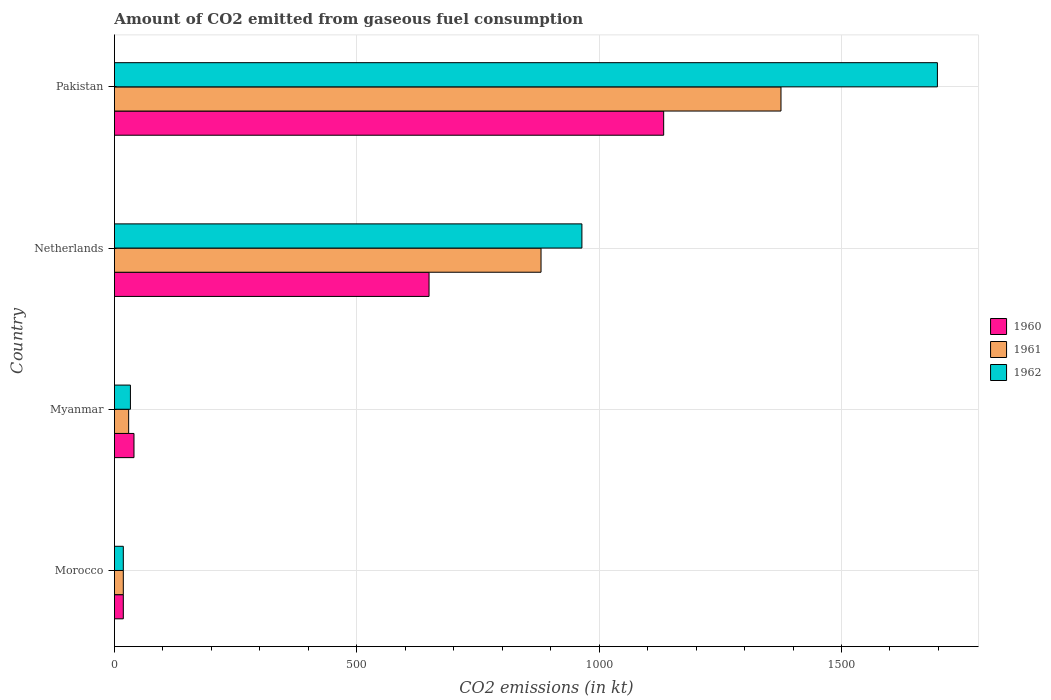How many groups of bars are there?
Give a very brief answer. 4. Are the number of bars on each tick of the Y-axis equal?
Your answer should be compact. Yes. What is the label of the 1st group of bars from the top?
Give a very brief answer. Pakistan. What is the amount of CO2 emitted in 1961 in Morocco?
Your answer should be very brief. 18.34. Across all countries, what is the maximum amount of CO2 emitted in 1962?
Provide a short and direct response. 1697.82. Across all countries, what is the minimum amount of CO2 emitted in 1960?
Your answer should be very brief. 18.34. In which country was the amount of CO2 emitted in 1960 minimum?
Your answer should be compact. Morocco. What is the total amount of CO2 emitted in 1962 in the graph?
Your response must be concise. 2713.58. What is the difference between the amount of CO2 emitted in 1962 in Morocco and that in Myanmar?
Your response must be concise. -14.67. What is the difference between the amount of CO2 emitted in 1961 in Netherlands and the amount of CO2 emitted in 1962 in Morocco?
Provide a succinct answer. 861.75. What is the average amount of CO2 emitted in 1960 per country?
Ensure brevity in your answer.  460.21. What is the difference between the amount of CO2 emitted in 1962 and amount of CO2 emitted in 1961 in Myanmar?
Your answer should be very brief. 3.67. In how many countries, is the amount of CO2 emitted in 1962 greater than 400 kt?
Provide a short and direct response. 2. What is the ratio of the amount of CO2 emitted in 1960 in Morocco to that in Pakistan?
Keep it short and to the point. 0.02. Is the difference between the amount of CO2 emitted in 1962 in Morocco and Myanmar greater than the difference between the amount of CO2 emitted in 1961 in Morocco and Myanmar?
Give a very brief answer. No. What is the difference between the highest and the second highest amount of CO2 emitted in 1962?
Your response must be concise. 733.4. What is the difference between the highest and the lowest amount of CO2 emitted in 1960?
Your response must be concise. 1114.77. In how many countries, is the amount of CO2 emitted in 1960 greater than the average amount of CO2 emitted in 1960 taken over all countries?
Offer a very short reply. 2. What does the 2nd bar from the top in Myanmar represents?
Provide a short and direct response. 1961. Is it the case that in every country, the sum of the amount of CO2 emitted in 1961 and amount of CO2 emitted in 1960 is greater than the amount of CO2 emitted in 1962?
Your response must be concise. Yes. Are all the bars in the graph horizontal?
Provide a short and direct response. Yes. How many countries are there in the graph?
Provide a short and direct response. 4. Are the values on the major ticks of X-axis written in scientific E-notation?
Your response must be concise. No. How are the legend labels stacked?
Make the answer very short. Vertical. What is the title of the graph?
Your answer should be compact. Amount of CO2 emitted from gaseous fuel consumption. What is the label or title of the X-axis?
Ensure brevity in your answer.  CO2 emissions (in kt). What is the CO2 emissions (in kt) in 1960 in Morocco?
Your answer should be very brief. 18.34. What is the CO2 emissions (in kt) of 1961 in Morocco?
Provide a succinct answer. 18.34. What is the CO2 emissions (in kt) in 1962 in Morocco?
Your response must be concise. 18.34. What is the CO2 emissions (in kt) in 1960 in Myanmar?
Keep it short and to the point. 40.34. What is the CO2 emissions (in kt) of 1961 in Myanmar?
Your response must be concise. 29.34. What is the CO2 emissions (in kt) in 1962 in Myanmar?
Provide a short and direct response. 33. What is the CO2 emissions (in kt) in 1960 in Netherlands?
Make the answer very short. 649.06. What is the CO2 emissions (in kt) of 1961 in Netherlands?
Provide a succinct answer. 880.08. What is the CO2 emissions (in kt) in 1962 in Netherlands?
Offer a terse response. 964.42. What is the CO2 emissions (in kt) of 1960 in Pakistan?
Provide a succinct answer. 1133.1. What is the CO2 emissions (in kt) of 1961 in Pakistan?
Your response must be concise. 1375.12. What is the CO2 emissions (in kt) in 1962 in Pakistan?
Give a very brief answer. 1697.82. Across all countries, what is the maximum CO2 emissions (in kt) in 1960?
Keep it short and to the point. 1133.1. Across all countries, what is the maximum CO2 emissions (in kt) in 1961?
Your response must be concise. 1375.12. Across all countries, what is the maximum CO2 emissions (in kt) of 1962?
Your answer should be very brief. 1697.82. Across all countries, what is the minimum CO2 emissions (in kt) of 1960?
Keep it short and to the point. 18.34. Across all countries, what is the minimum CO2 emissions (in kt) of 1961?
Offer a terse response. 18.34. Across all countries, what is the minimum CO2 emissions (in kt) of 1962?
Keep it short and to the point. 18.34. What is the total CO2 emissions (in kt) in 1960 in the graph?
Offer a very short reply. 1840.83. What is the total CO2 emissions (in kt) of 1961 in the graph?
Give a very brief answer. 2302.88. What is the total CO2 emissions (in kt) of 1962 in the graph?
Offer a terse response. 2713.58. What is the difference between the CO2 emissions (in kt) of 1960 in Morocco and that in Myanmar?
Your answer should be compact. -22. What is the difference between the CO2 emissions (in kt) of 1961 in Morocco and that in Myanmar?
Your answer should be compact. -11. What is the difference between the CO2 emissions (in kt) of 1962 in Morocco and that in Myanmar?
Your response must be concise. -14.67. What is the difference between the CO2 emissions (in kt) in 1960 in Morocco and that in Netherlands?
Ensure brevity in your answer.  -630.72. What is the difference between the CO2 emissions (in kt) of 1961 in Morocco and that in Netherlands?
Keep it short and to the point. -861.75. What is the difference between the CO2 emissions (in kt) of 1962 in Morocco and that in Netherlands?
Offer a very short reply. -946.09. What is the difference between the CO2 emissions (in kt) of 1960 in Morocco and that in Pakistan?
Offer a terse response. -1114.77. What is the difference between the CO2 emissions (in kt) in 1961 in Morocco and that in Pakistan?
Ensure brevity in your answer.  -1356.79. What is the difference between the CO2 emissions (in kt) in 1962 in Morocco and that in Pakistan?
Offer a terse response. -1679.49. What is the difference between the CO2 emissions (in kt) of 1960 in Myanmar and that in Netherlands?
Make the answer very short. -608.72. What is the difference between the CO2 emissions (in kt) of 1961 in Myanmar and that in Netherlands?
Ensure brevity in your answer.  -850.74. What is the difference between the CO2 emissions (in kt) of 1962 in Myanmar and that in Netherlands?
Offer a terse response. -931.42. What is the difference between the CO2 emissions (in kt) in 1960 in Myanmar and that in Pakistan?
Provide a succinct answer. -1092.77. What is the difference between the CO2 emissions (in kt) in 1961 in Myanmar and that in Pakistan?
Ensure brevity in your answer.  -1345.79. What is the difference between the CO2 emissions (in kt) in 1962 in Myanmar and that in Pakistan?
Your answer should be compact. -1664.82. What is the difference between the CO2 emissions (in kt) in 1960 in Netherlands and that in Pakistan?
Make the answer very short. -484.04. What is the difference between the CO2 emissions (in kt) in 1961 in Netherlands and that in Pakistan?
Provide a short and direct response. -495.05. What is the difference between the CO2 emissions (in kt) in 1962 in Netherlands and that in Pakistan?
Offer a terse response. -733.4. What is the difference between the CO2 emissions (in kt) of 1960 in Morocco and the CO2 emissions (in kt) of 1961 in Myanmar?
Provide a short and direct response. -11. What is the difference between the CO2 emissions (in kt) in 1960 in Morocco and the CO2 emissions (in kt) in 1962 in Myanmar?
Provide a short and direct response. -14.67. What is the difference between the CO2 emissions (in kt) of 1961 in Morocco and the CO2 emissions (in kt) of 1962 in Myanmar?
Provide a short and direct response. -14.67. What is the difference between the CO2 emissions (in kt) in 1960 in Morocco and the CO2 emissions (in kt) in 1961 in Netherlands?
Offer a very short reply. -861.75. What is the difference between the CO2 emissions (in kt) of 1960 in Morocco and the CO2 emissions (in kt) of 1962 in Netherlands?
Give a very brief answer. -946.09. What is the difference between the CO2 emissions (in kt) in 1961 in Morocco and the CO2 emissions (in kt) in 1962 in Netherlands?
Provide a short and direct response. -946.09. What is the difference between the CO2 emissions (in kt) in 1960 in Morocco and the CO2 emissions (in kt) in 1961 in Pakistan?
Keep it short and to the point. -1356.79. What is the difference between the CO2 emissions (in kt) in 1960 in Morocco and the CO2 emissions (in kt) in 1962 in Pakistan?
Provide a succinct answer. -1679.49. What is the difference between the CO2 emissions (in kt) in 1961 in Morocco and the CO2 emissions (in kt) in 1962 in Pakistan?
Your answer should be very brief. -1679.49. What is the difference between the CO2 emissions (in kt) of 1960 in Myanmar and the CO2 emissions (in kt) of 1961 in Netherlands?
Provide a short and direct response. -839.74. What is the difference between the CO2 emissions (in kt) in 1960 in Myanmar and the CO2 emissions (in kt) in 1962 in Netherlands?
Ensure brevity in your answer.  -924.08. What is the difference between the CO2 emissions (in kt) in 1961 in Myanmar and the CO2 emissions (in kt) in 1962 in Netherlands?
Ensure brevity in your answer.  -935.09. What is the difference between the CO2 emissions (in kt) of 1960 in Myanmar and the CO2 emissions (in kt) of 1961 in Pakistan?
Offer a terse response. -1334.79. What is the difference between the CO2 emissions (in kt) of 1960 in Myanmar and the CO2 emissions (in kt) of 1962 in Pakistan?
Provide a succinct answer. -1657.48. What is the difference between the CO2 emissions (in kt) in 1961 in Myanmar and the CO2 emissions (in kt) in 1962 in Pakistan?
Give a very brief answer. -1668.48. What is the difference between the CO2 emissions (in kt) of 1960 in Netherlands and the CO2 emissions (in kt) of 1961 in Pakistan?
Your response must be concise. -726.07. What is the difference between the CO2 emissions (in kt) of 1960 in Netherlands and the CO2 emissions (in kt) of 1962 in Pakistan?
Your response must be concise. -1048.76. What is the difference between the CO2 emissions (in kt) of 1961 in Netherlands and the CO2 emissions (in kt) of 1962 in Pakistan?
Offer a very short reply. -817.74. What is the average CO2 emissions (in kt) in 1960 per country?
Your answer should be very brief. 460.21. What is the average CO2 emissions (in kt) in 1961 per country?
Provide a short and direct response. 575.72. What is the average CO2 emissions (in kt) in 1962 per country?
Offer a terse response. 678.39. What is the difference between the CO2 emissions (in kt) of 1960 and CO2 emissions (in kt) of 1962 in Morocco?
Your answer should be compact. 0. What is the difference between the CO2 emissions (in kt) in 1961 and CO2 emissions (in kt) in 1962 in Morocco?
Your response must be concise. 0. What is the difference between the CO2 emissions (in kt) of 1960 and CO2 emissions (in kt) of 1961 in Myanmar?
Keep it short and to the point. 11. What is the difference between the CO2 emissions (in kt) of 1960 and CO2 emissions (in kt) of 1962 in Myanmar?
Provide a short and direct response. 7.33. What is the difference between the CO2 emissions (in kt) of 1961 and CO2 emissions (in kt) of 1962 in Myanmar?
Make the answer very short. -3.67. What is the difference between the CO2 emissions (in kt) in 1960 and CO2 emissions (in kt) in 1961 in Netherlands?
Offer a very short reply. -231.02. What is the difference between the CO2 emissions (in kt) of 1960 and CO2 emissions (in kt) of 1962 in Netherlands?
Your answer should be very brief. -315.36. What is the difference between the CO2 emissions (in kt) in 1961 and CO2 emissions (in kt) in 1962 in Netherlands?
Ensure brevity in your answer.  -84.34. What is the difference between the CO2 emissions (in kt) of 1960 and CO2 emissions (in kt) of 1961 in Pakistan?
Keep it short and to the point. -242.02. What is the difference between the CO2 emissions (in kt) of 1960 and CO2 emissions (in kt) of 1962 in Pakistan?
Your response must be concise. -564.72. What is the difference between the CO2 emissions (in kt) of 1961 and CO2 emissions (in kt) of 1962 in Pakistan?
Offer a terse response. -322.7. What is the ratio of the CO2 emissions (in kt) of 1960 in Morocco to that in Myanmar?
Your answer should be compact. 0.45. What is the ratio of the CO2 emissions (in kt) in 1962 in Morocco to that in Myanmar?
Your answer should be very brief. 0.56. What is the ratio of the CO2 emissions (in kt) in 1960 in Morocco to that in Netherlands?
Give a very brief answer. 0.03. What is the ratio of the CO2 emissions (in kt) of 1961 in Morocco to that in Netherlands?
Make the answer very short. 0.02. What is the ratio of the CO2 emissions (in kt) of 1962 in Morocco to that in Netherlands?
Provide a short and direct response. 0.02. What is the ratio of the CO2 emissions (in kt) of 1960 in Morocco to that in Pakistan?
Provide a succinct answer. 0.02. What is the ratio of the CO2 emissions (in kt) in 1961 in Morocco to that in Pakistan?
Keep it short and to the point. 0.01. What is the ratio of the CO2 emissions (in kt) in 1962 in Morocco to that in Pakistan?
Ensure brevity in your answer.  0.01. What is the ratio of the CO2 emissions (in kt) in 1960 in Myanmar to that in Netherlands?
Provide a short and direct response. 0.06. What is the ratio of the CO2 emissions (in kt) in 1962 in Myanmar to that in Netherlands?
Offer a terse response. 0.03. What is the ratio of the CO2 emissions (in kt) in 1960 in Myanmar to that in Pakistan?
Your response must be concise. 0.04. What is the ratio of the CO2 emissions (in kt) of 1961 in Myanmar to that in Pakistan?
Offer a terse response. 0.02. What is the ratio of the CO2 emissions (in kt) in 1962 in Myanmar to that in Pakistan?
Provide a succinct answer. 0.02. What is the ratio of the CO2 emissions (in kt) of 1960 in Netherlands to that in Pakistan?
Ensure brevity in your answer.  0.57. What is the ratio of the CO2 emissions (in kt) in 1961 in Netherlands to that in Pakistan?
Offer a very short reply. 0.64. What is the ratio of the CO2 emissions (in kt) of 1962 in Netherlands to that in Pakistan?
Offer a very short reply. 0.57. What is the difference between the highest and the second highest CO2 emissions (in kt) of 1960?
Provide a succinct answer. 484.04. What is the difference between the highest and the second highest CO2 emissions (in kt) in 1961?
Offer a terse response. 495.05. What is the difference between the highest and the second highest CO2 emissions (in kt) of 1962?
Offer a terse response. 733.4. What is the difference between the highest and the lowest CO2 emissions (in kt) in 1960?
Ensure brevity in your answer.  1114.77. What is the difference between the highest and the lowest CO2 emissions (in kt) of 1961?
Your response must be concise. 1356.79. What is the difference between the highest and the lowest CO2 emissions (in kt) of 1962?
Offer a very short reply. 1679.49. 